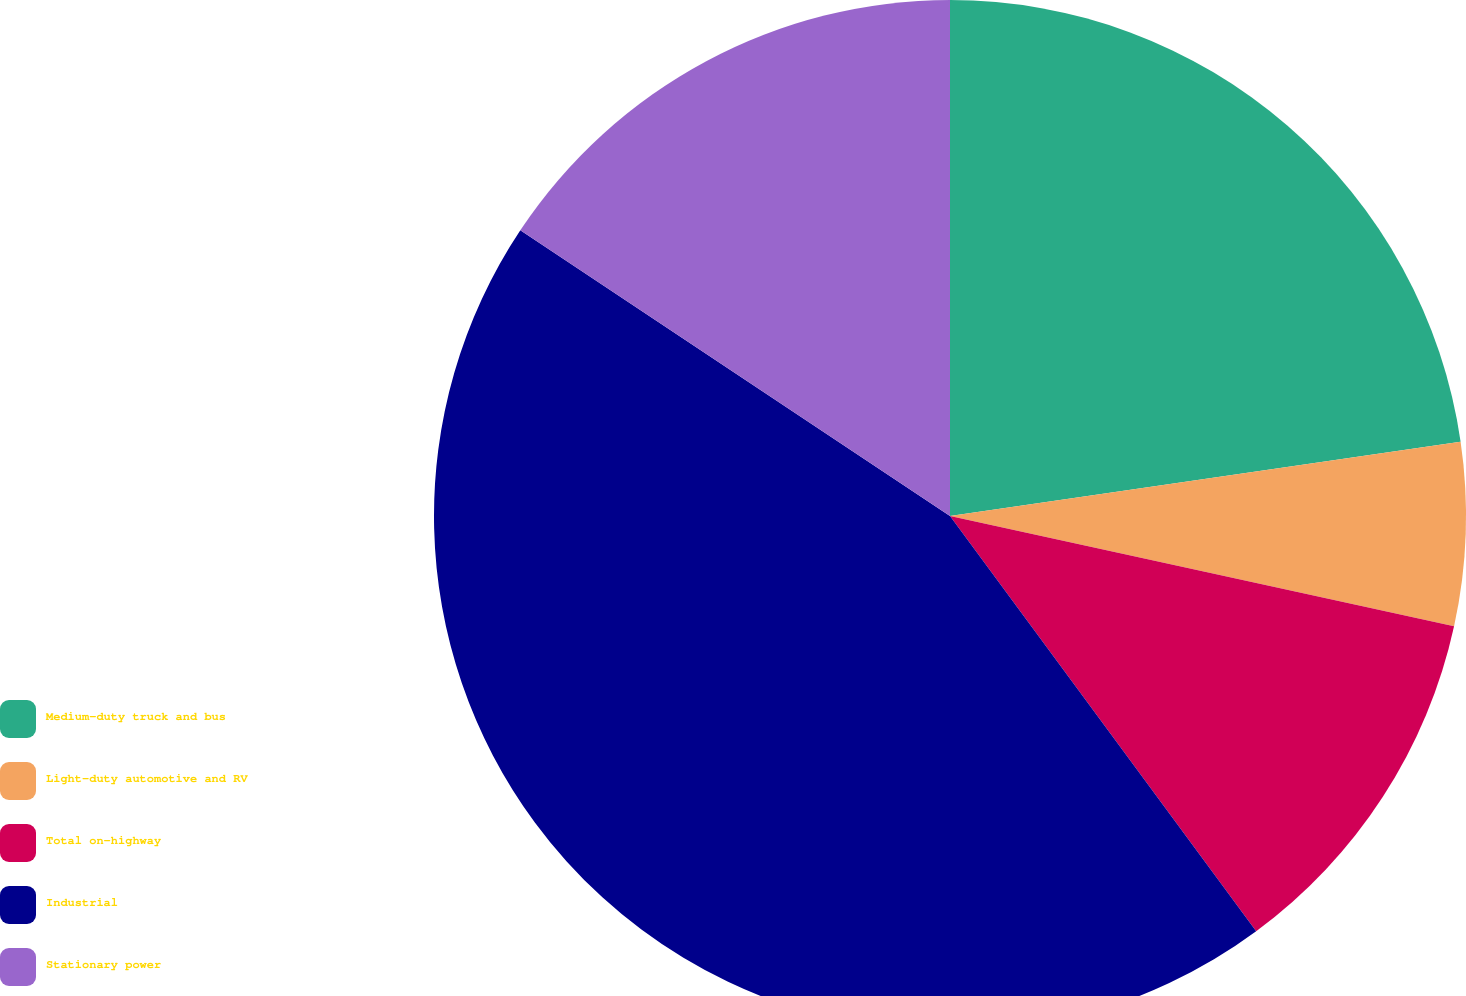Convert chart to OTSL. <chart><loc_0><loc_0><loc_500><loc_500><pie_chart><fcel>Medium-duty truck and bus<fcel>Light-duty automotive and RV<fcel>Total on-highway<fcel>Industrial<fcel>Stationary power<nl><fcel>22.7%<fcel>5.73%<fcel>11.46%<fcel>44.45%<fcel>15.66%<nl></chart> 